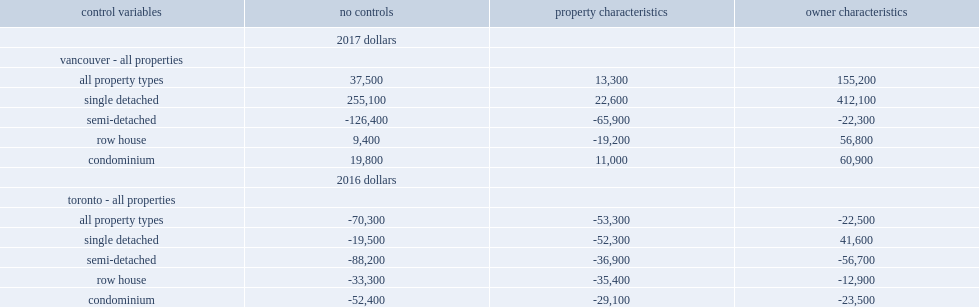How much lower average assessment value do immigrant owned, single-detached houses in toronto have than those owned by canadian-born residents on an unadjusted basis? -19500.0. How much lower average assessment value do immigrant owned, single-detached houses in toronto have than those owned by canadian-born residents after adjusting for size, age, and location? -52300.0. Which negative gap is wider, on an unadjusted basis or after adjusting for size, age, and location? Property characteristics. What is the unadjusted difference in single-detached homes in vancouver? 255100.0. What is the difference in single-detached homes when controlling for differences in the age and family income of owners in vancouver? 412100.0. Which difference in single-detached homes is higher in vancouver, on a unadjusted basis or when controlling for differences in the age and family income of owners? Owner characteristics. How much positive difference do single-detached homes in toronto have when controlling for owner age and income? 41600.0. Which difference in single-detached homes is higher in toronto, on a unadjusted basis or when controlling for owner age and income? Owner characteristics. 